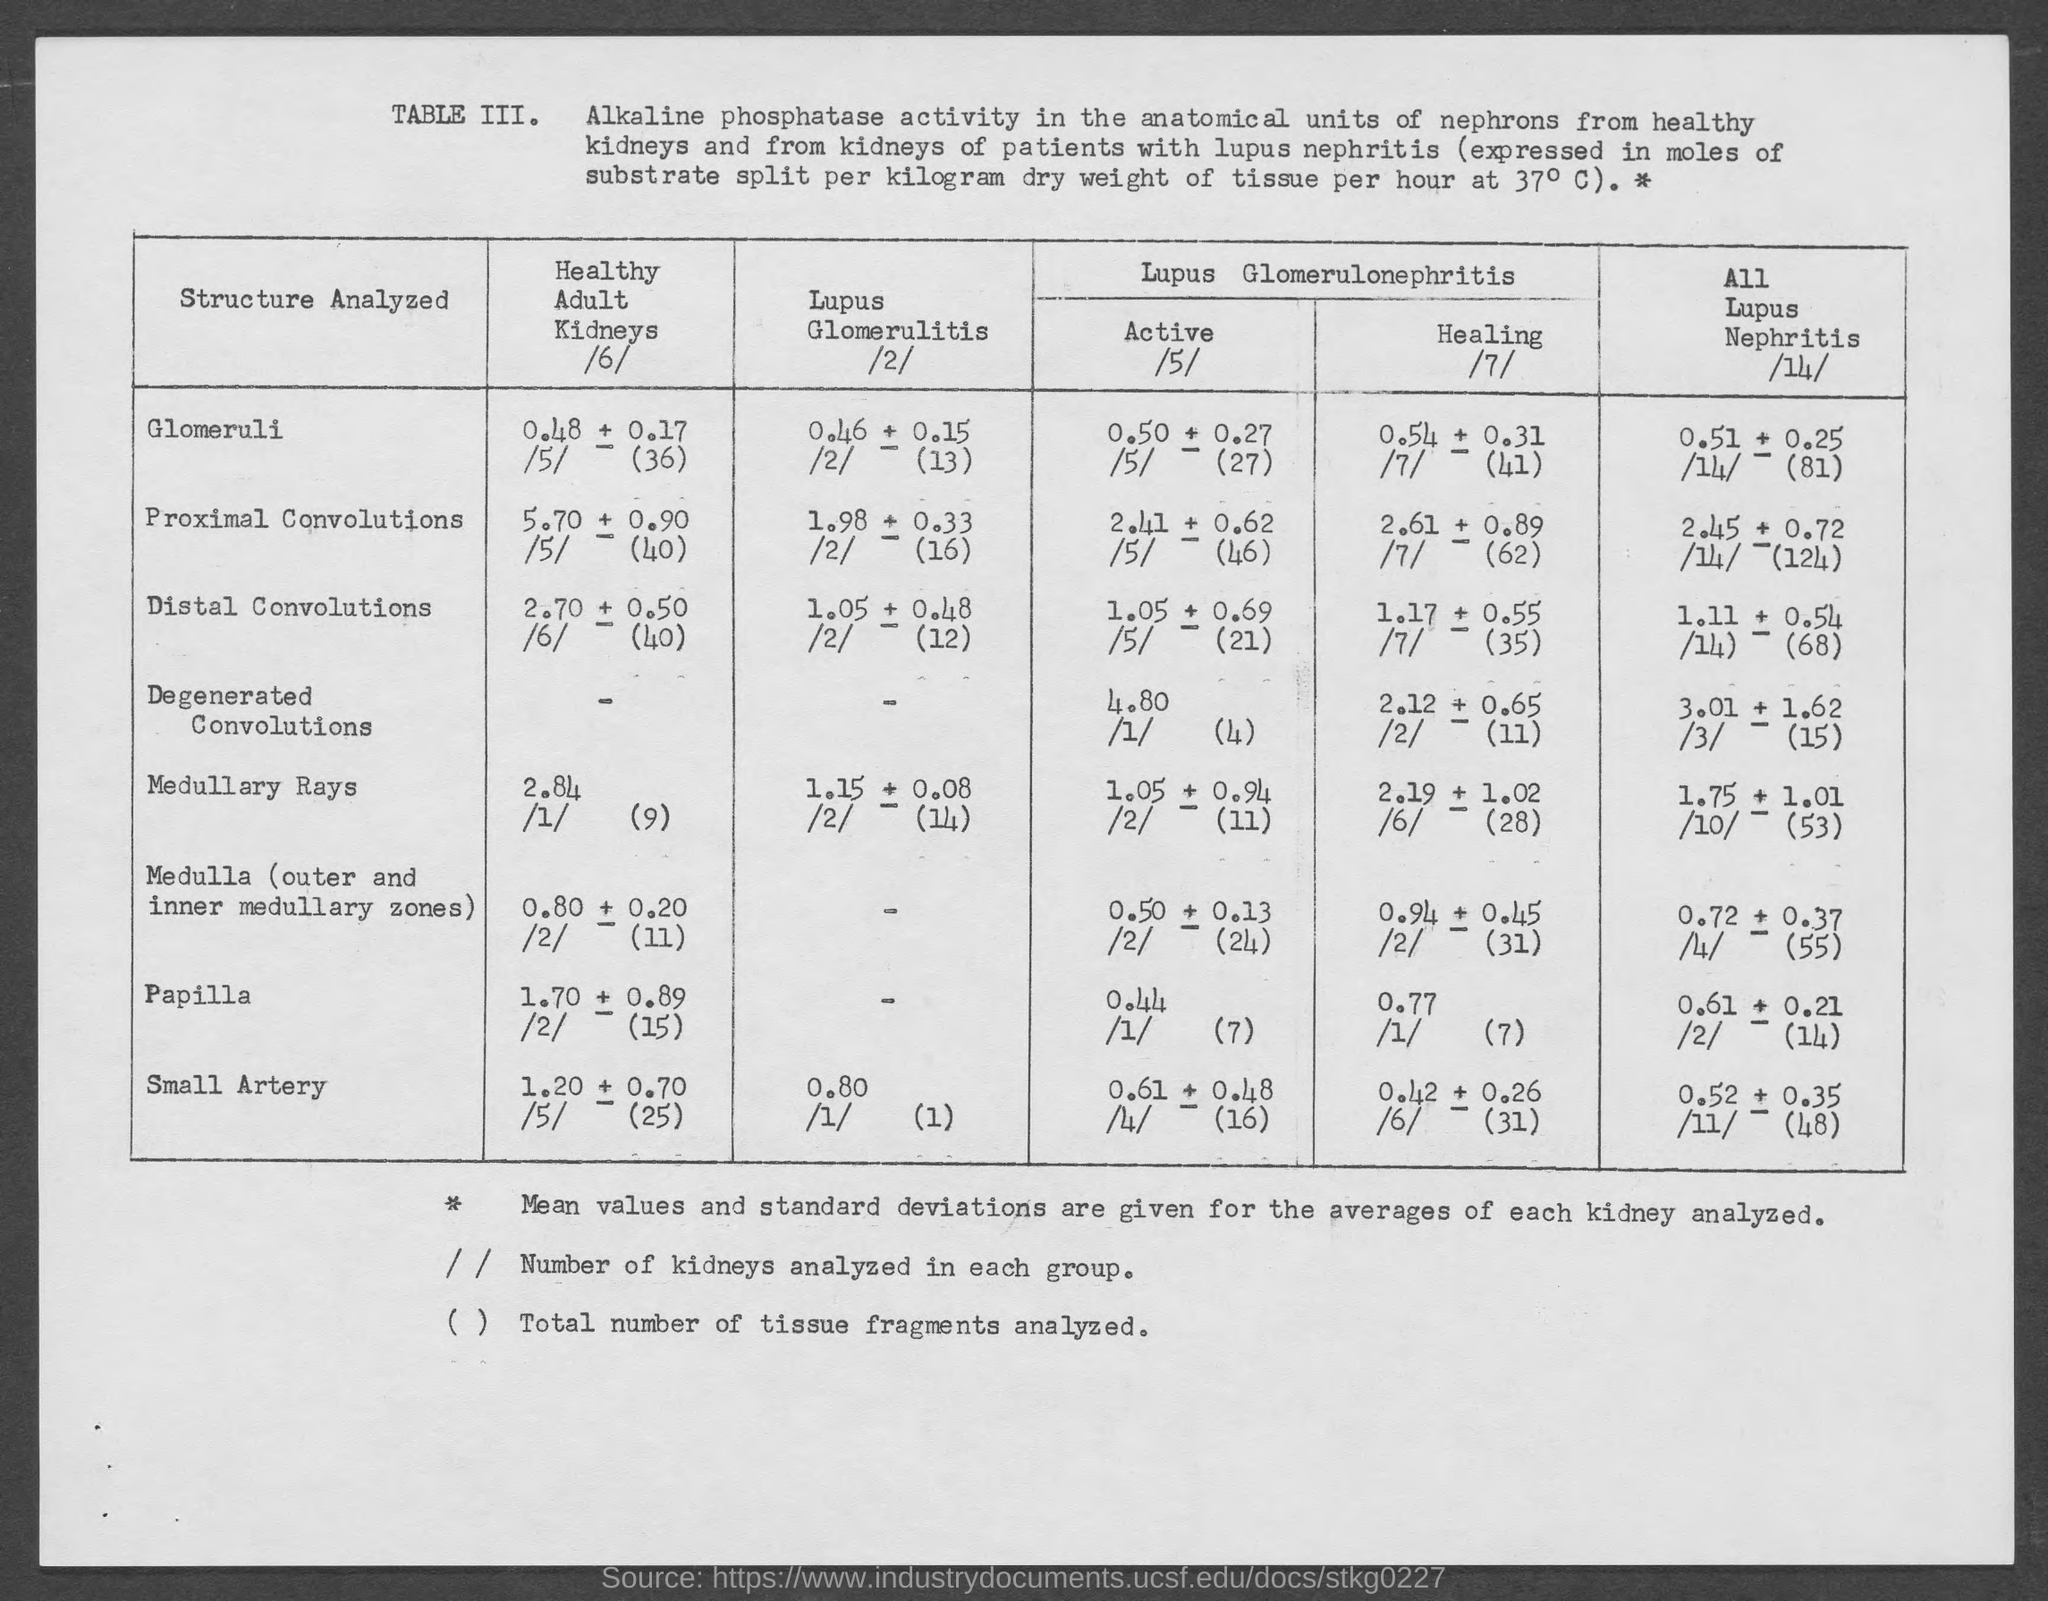What is the value given for "Lupus Glomerulitis" for "Small Artery" structure analyzed?
Offer a very short reply. 0.80. 